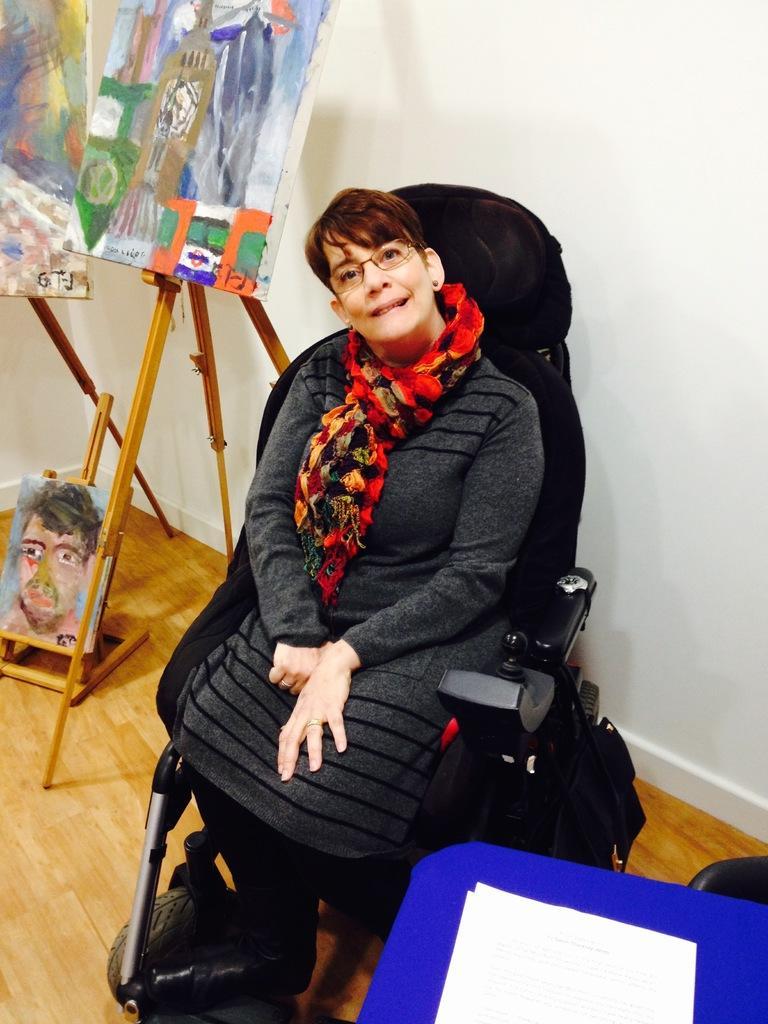Describe this image in one or two sentences. In this image we can see a woman wearing a dress and spectacles is sitting in a chair with wheel. On the left side of the image we can see group of paintings on stands. In the foreground we can see a paper placed on the table. In the background, we can see the wall. 